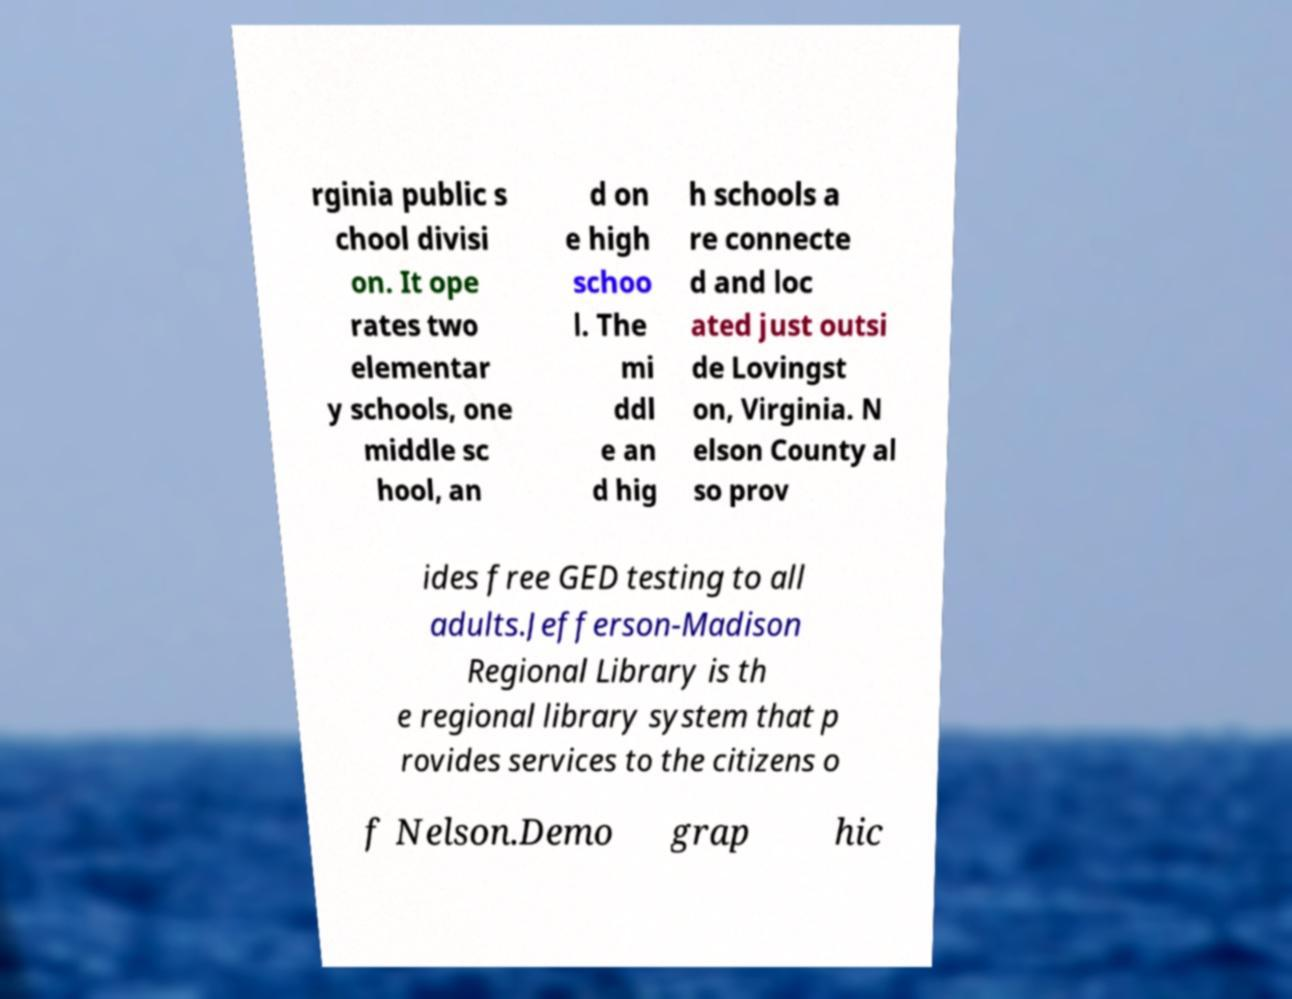For documentation purposes, I need the text within this image transcribed. Could you provide that? rginia public s chool divisi on. It ope rates two elementar y schools, one middle sc hool, an d on e high schoo l. The mi ddl e an d hig h schools a re connecte d and loc ated just outsi de Lovingst on, Virginia. N elson County al so prov ides free GED testing to all adults.Jefferson-Madison Regional Library is th e regional library system that p rovides services to the citizens o f Nelson.Demo grap hic 